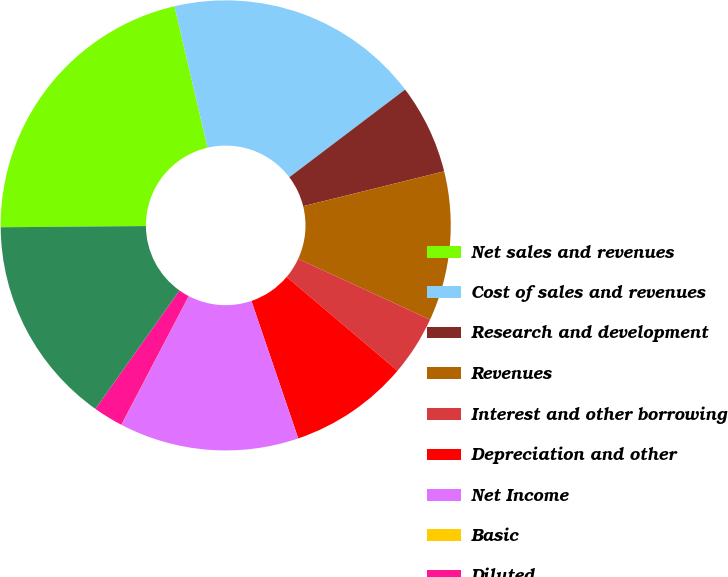Convert chart. <chart><loc_0><loc_0><loc_500><loc_500><pie_chart><fcel>Net sales and revenues<fcel>Cost of sales and revenues<fcel>Research and development<fcel>Revenues<fcel>Interest and other borrowing<fcel>Depreciation and other<fcel>Net Income<fcel>Basic<fcel>Diluted<fcel>Net (Loss) Income<nl><fcel>21.48%<fcel>18.34%<fcel>6.45%<fcel>10.74%<fcel>4.3%<fcel>8.6%<fcel>12.89%<fcel>0.01%<fcel>2.15%<fcel>15.04%<nl></chart> 